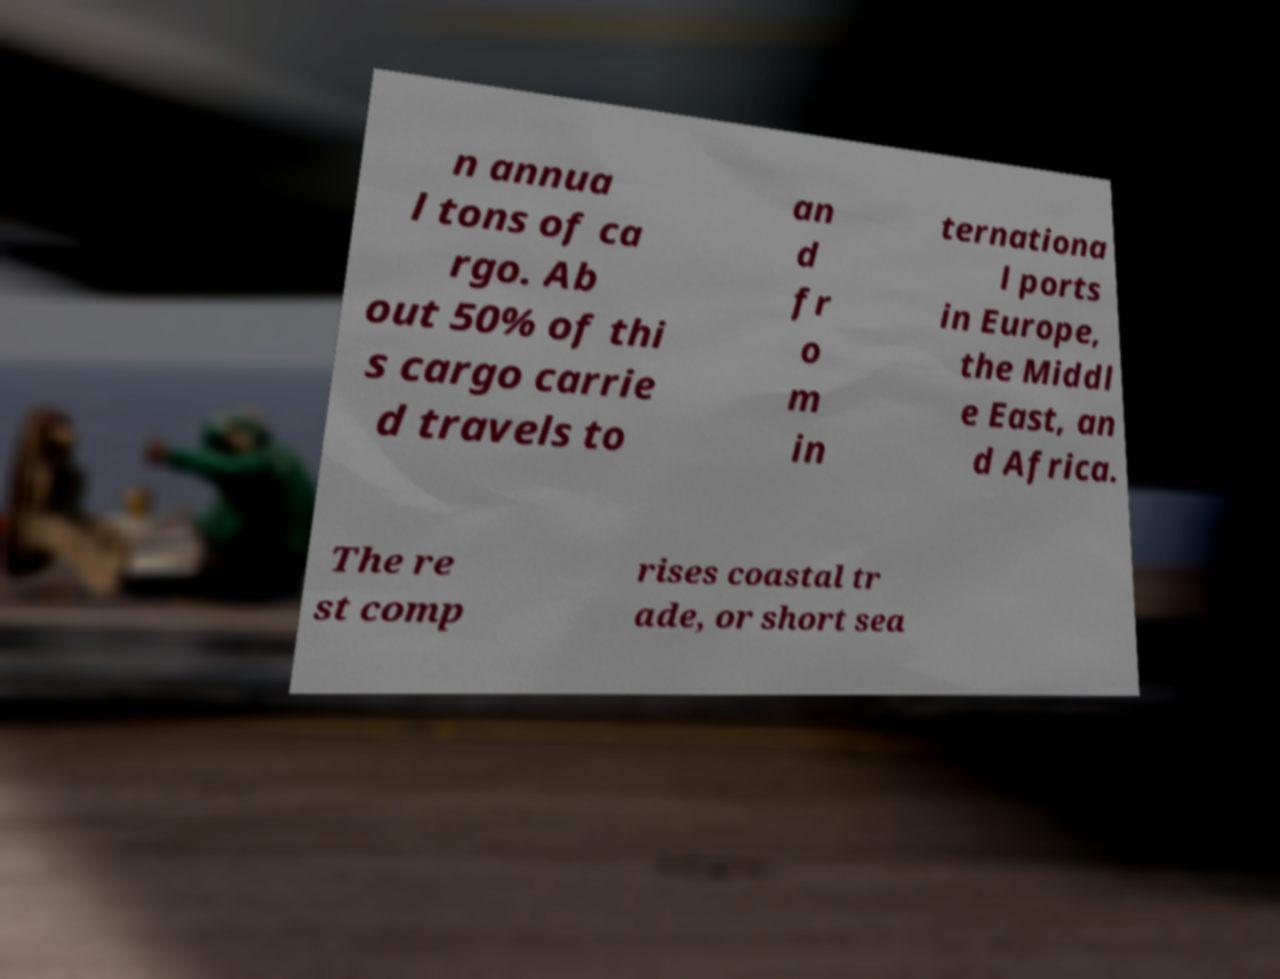There's text embedded in this image that I need extracted. Can you transcribe it verbatim? n annua l tons of ca rgo. Ab out 50% of thi s cargo carrie d travels to an d fr o m in ternationa l ports in Europe, the Middl e East, an d Africa. The re st comp rises coastal tr ade, or short sea 